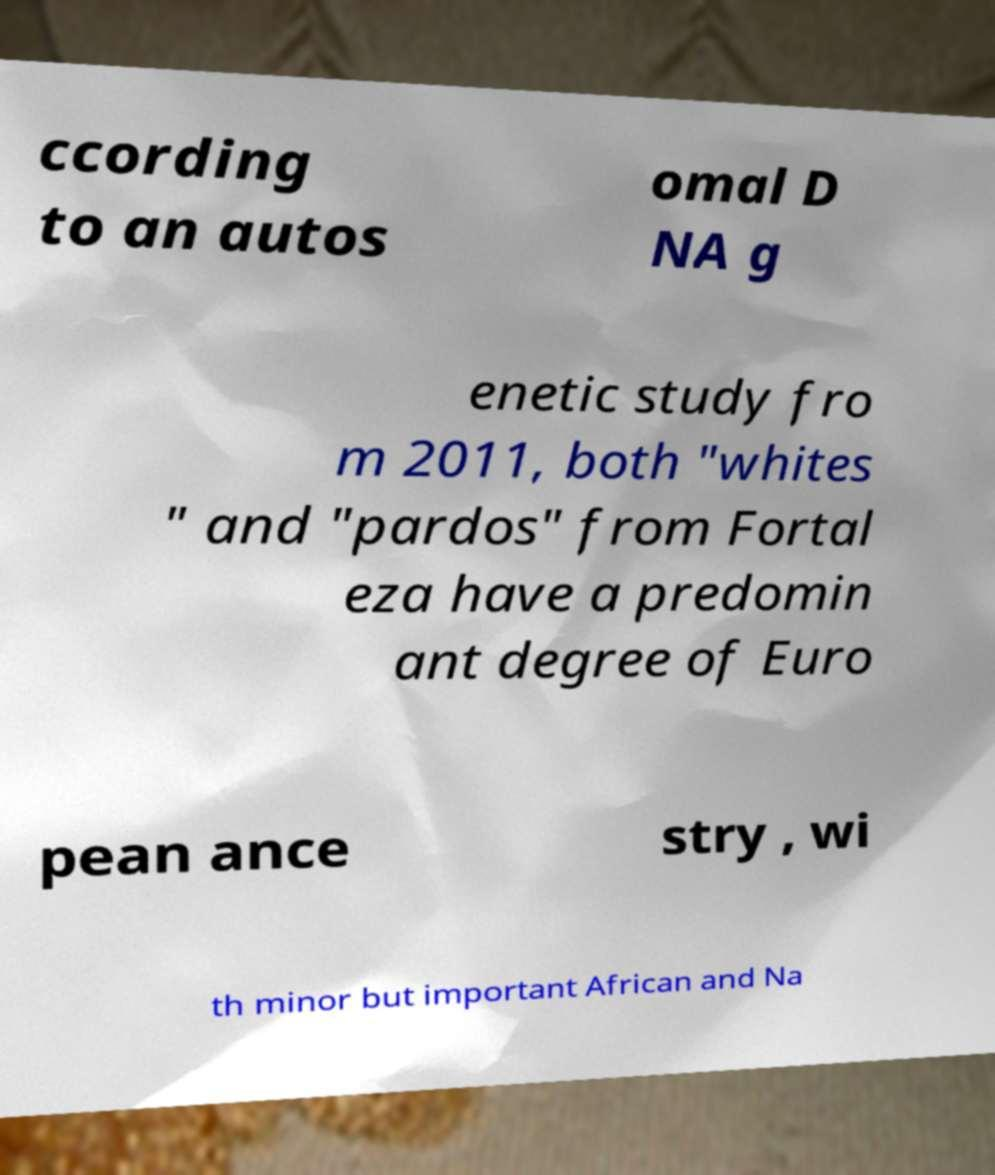For documentation purposes, I need the text within this image transcribed. Could you provide that? ccording to an autos omal D NA g enetic study fro m 2011, both "whites " and "pardos" from Fortal eza have a predomin ant degree of Euro pean ance stry , wi th minor but important African and Na 